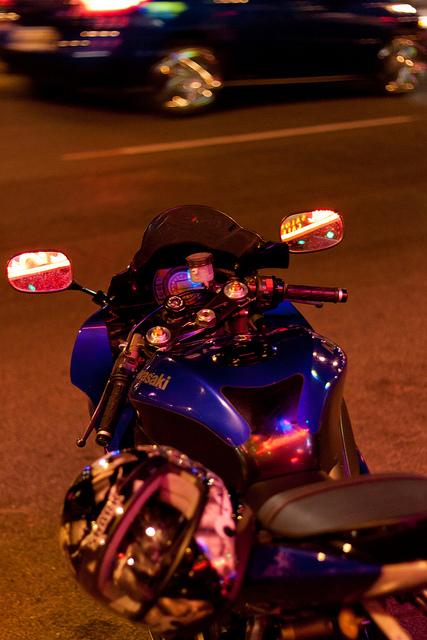Does this motorcycle have two mirrors?
Quick response, please. Yes. What color is the bikes pant?
Be succinct. Blue. What color are the tires on the bike?
Keep it brief. Black. 